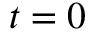<formula> <loc_0><loc_0><loc_500><loc_500>t = 0</formula> 